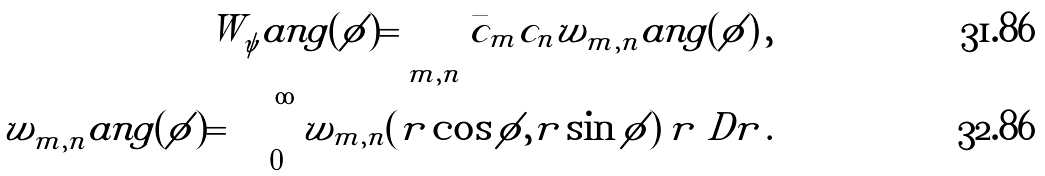Convert formula to latex. <formula><loc_0><loc_0><loc_500><loc_500>W _ { \psi } ^ { \ } a n g ( \phi ) = \sum _ { m , n } \bar { c } _ { m } c _ { n } w _ { m , n } ^ { \ } a n g ( \phi ) \, , \\ w _ { m , n } ^ { \ } a n g ( \phi ) = \int _ { 0 } ^ { \infty } w _ { m , n } ( r \cos \phi , r \sin \phi ) \, r \ D r \, .</formula> 